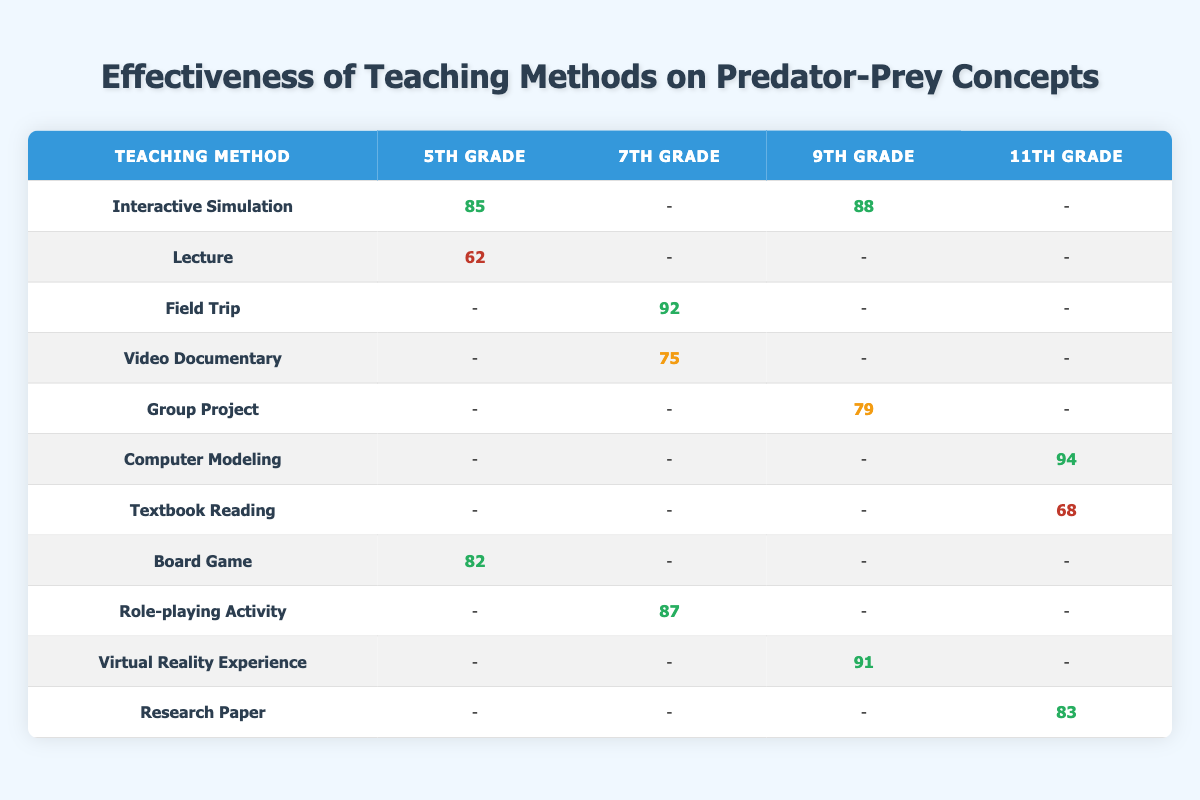What was the highest student understanding score recorded in the 5th Grade? From the table, the highest student understanding score for the 5th Grade is from the Interactive Simulation method with a score of 85.
Answer: 85 Which teaching method had the lowest engagement level in 11th Grade? In the 11th Grade, the Textbook Reading method is the only one listed with a low engagement level.
Answer: Yes What is the average student understanding score for the teaching methods listed in 9th Grade? The teaching methods for 9th Grade are Interactive Simulation (88), Group Project (79), and Virtual Reality Experience (91). The average score is calculated as (88 + 79 + 91) / 3 = 86.
Answer: 86 Did any teaching method in 7th Grade achieve a student understanding score above 90? In the 7th Grade, the Field Trip method scored 92, which is above 90.
Answer: Yes Which teaching method resulted in the highest student understanding score across all grades? From the table, the Computer Modeling method in 11th Grade has the highest student understanding score of 94. Therefore, it is the highest.
Answer: 94 What is the difference in student understanding scores between the best and worst performing teaching methods at the 5th Grade level? The best performing method is Interactive Simulation with a score of 85, and the worst is Lecture with a score of 62. The difference is 85 - 62 = 23.
Answer: 23 How many teaching methods showed a high engagement level in 9th Grade? In 9th Grade, the Interactive Simulation (high) and Virtual Reality Experience (very high) methods exhibit high levels of engagement. Therefore, there are 2 methods.
Answer: 2 Is the average retention rate for 11th Grade teaching methods higher than 80? The retention rates for 11th Grade methods are Computer Modeling (90), Textbook Reading (55), and Research Paper (77). The average is calculated as (90 + 55 + 77) / 3 = 74. Therefore, it is not higher than 80.
Answer: No What was the student understanding score for the Board Game method in 5th Grade? The Board Game method in 5th Grade achieved a student understanding score of 82, according to the table.
Answer: 82 